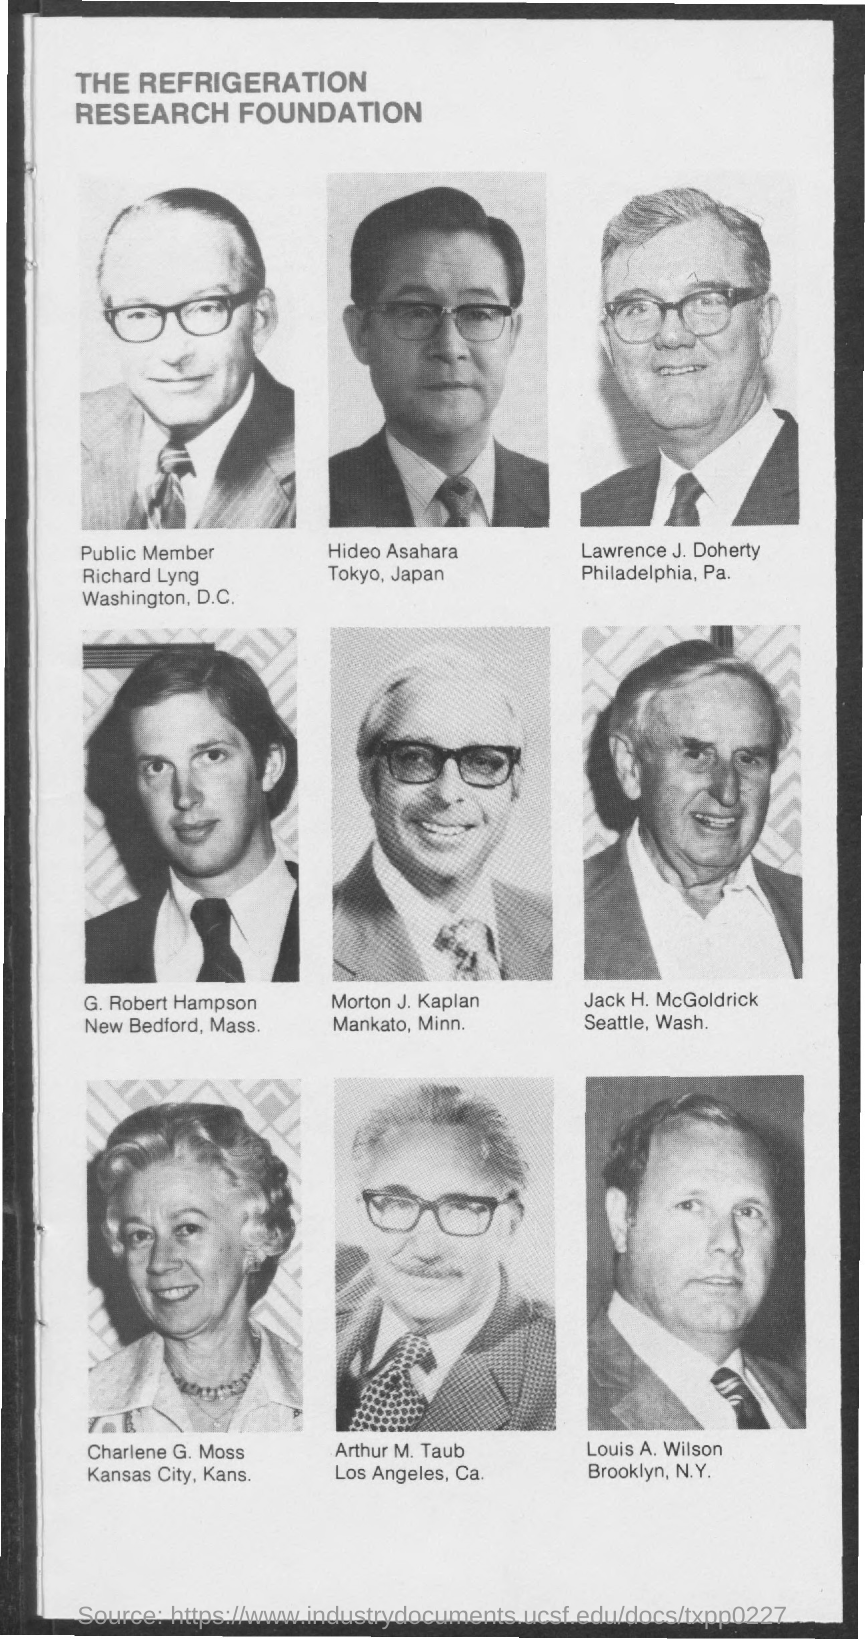Indicate a few pertinent items in this graphic. The title of the document is "The Refrigeration Research Foundation. 